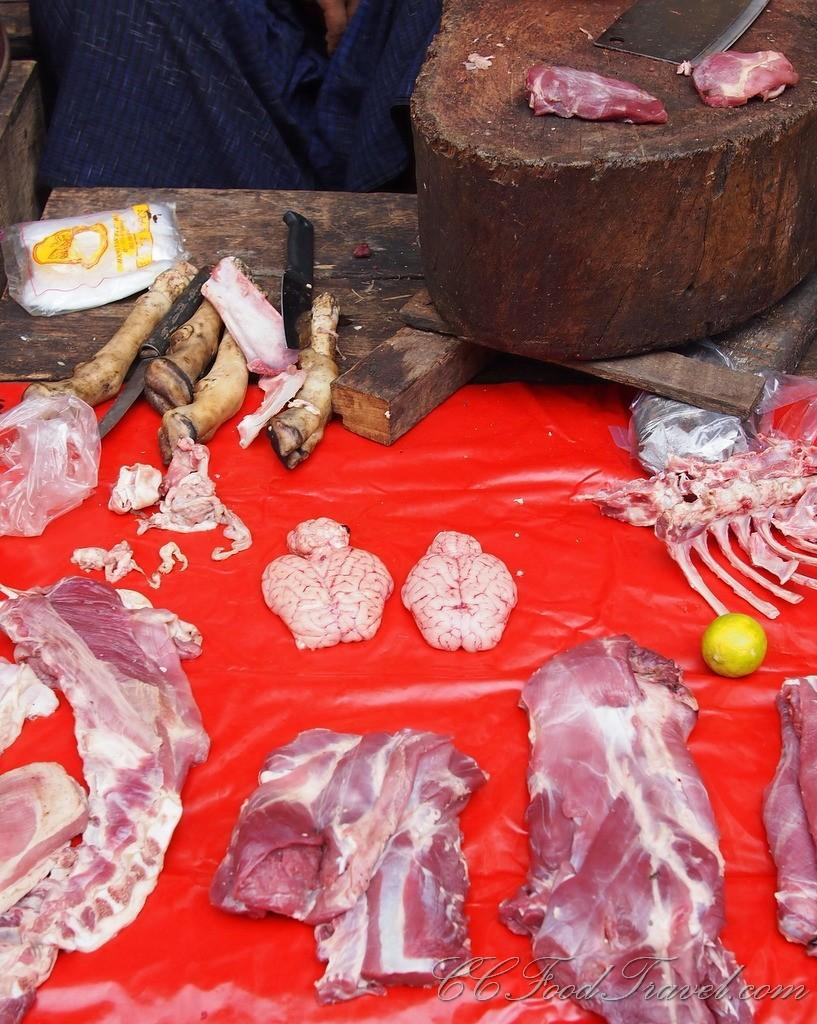What type of material is visible in the image? There is flesh and bones in the image. What surface is present in the image? There is a chopping pad in the image. Can you describe any other objects or elements in the image? There are other unspecified things in the image. What type of orange is being peeled by the society in the image? There is no orange or society present in the image; it features flesh and bones on a chopping pad. 